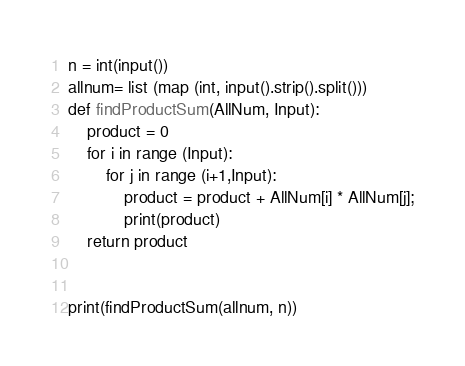<code> <loc_0><loc_0><loc_500><loc_500><_Python_>n = int(input())
allnum= list (map (int, input().strip().split()))
def findProductSum(AllNum, Input):
    product = 0
    for i in range (Input):
        for j in range (i+1,Input):
            product = product + AllNum[i] * AllNum[j];
            print(product)
    return product


print(findProductSum(allnum, n))
</code> 